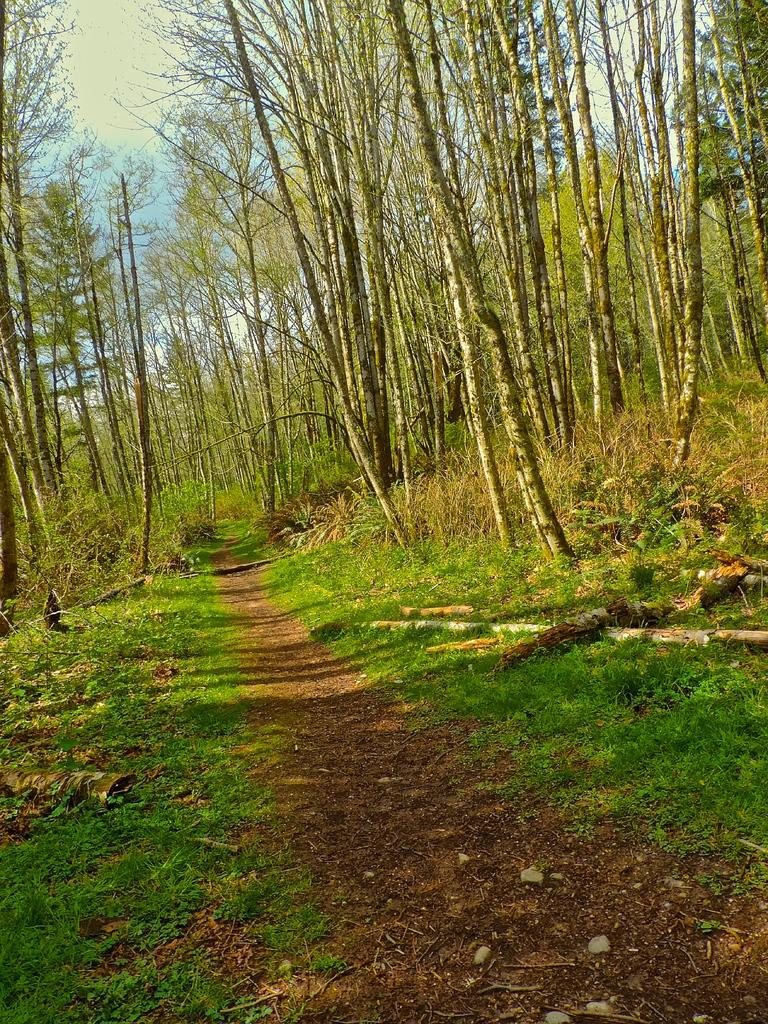What is the primary feature of the landscape in the image? There are many trees in the image. What type of road can be seen in the image? There is a mud road in the middle of the image. What are the hobbies of the trees in the image? Trees do not have hobbies, as they are inanimate objects. 